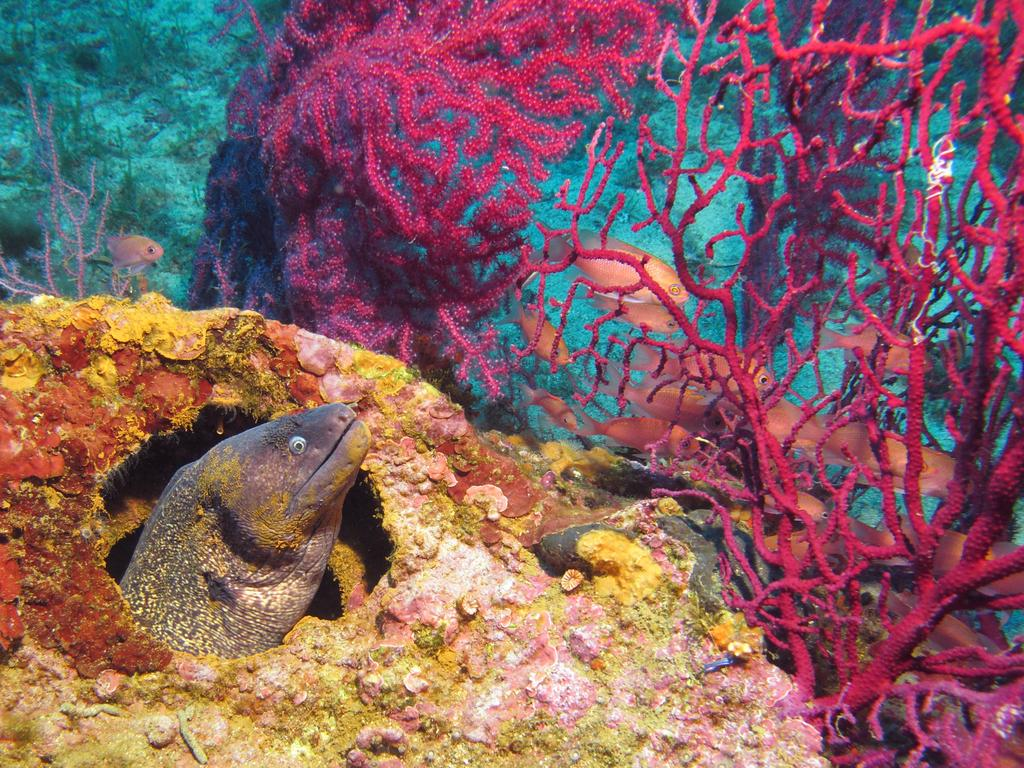What type of environment is shown in the image? The image depicts a scene inside the sea. What living creatures can be seen in the image? There are fishes visible in the image. What non-living objects are present in the image? There are sea rocks present in the image. What type of potato can be seen growing on the sea rocks in the image? There is no potato present in the image, as it takes place underwater in a marine environment. 